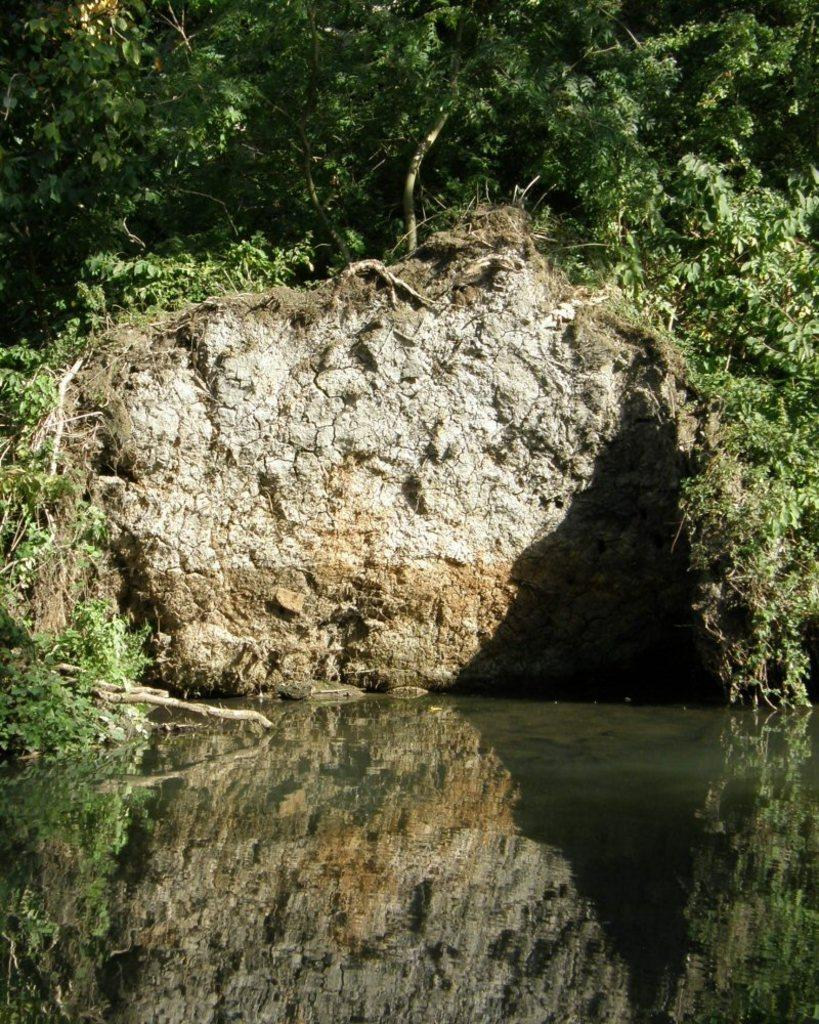What type of structure can be seen in the image? There is a wall in the image. What type of vegetation is present in the image? There are plants and grass in the image. What natural element is visible in the image? Water is visible in the image. What effect can be observed on the water's surface? Reflections are present on the water's surface. What type of mark can be seen on the apples in the image? There are no apples present in the image, so no marks can be observed on them. 